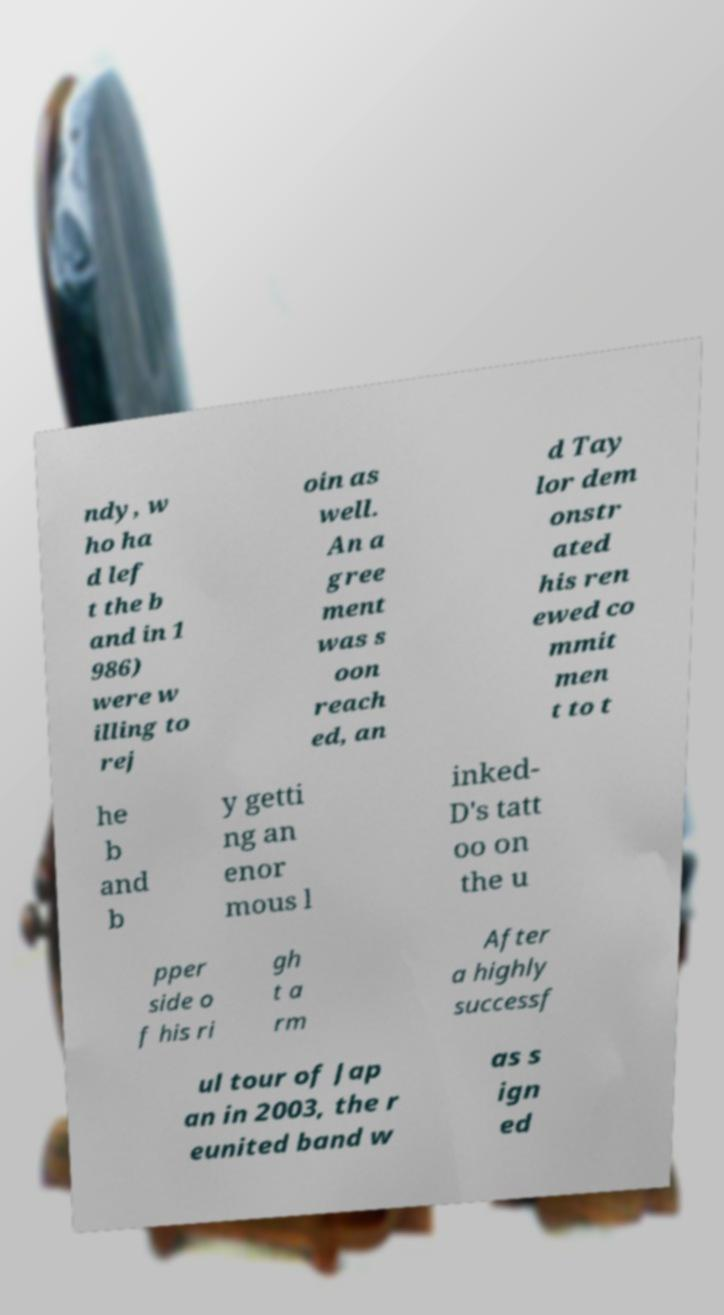Could you extract and type out the text from this image? ndy, w ho ha d lef t the b and in 1 986) were w illing to rej oin as well. An a gree ment was s oon reach ed, an d Tay lor dem onstr ated his ren ewed co mmit men t to t he b and b y getti ng an enor mous l inked- D's tatt oo on the u pper side o f his ri gh t a rm After a highly successf ul tour of Jap an in 2003, the r eunited band w as s ign ed 